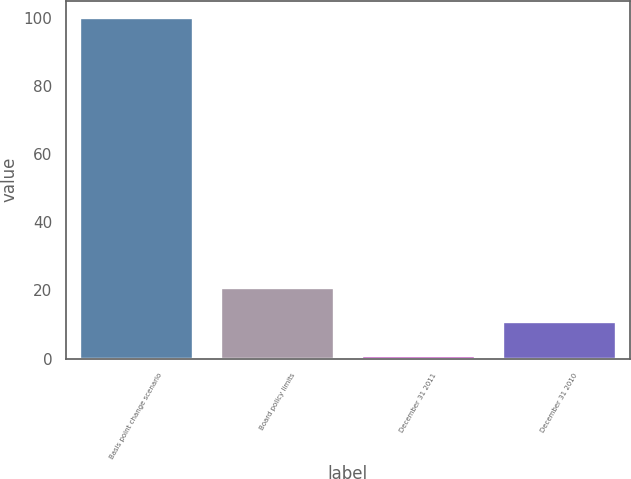Convert chart. <chart><loc_0><loc_0><loc_500><loc_500><bar_chart><fcel>Basis point change scenario<fcel>Board policy limits<fcel>December 31 2011<fcel>December 31 2010<nl><fcel>100<fcel>20.64<fcel>0.8<fcel>10.72<nl></chart> 